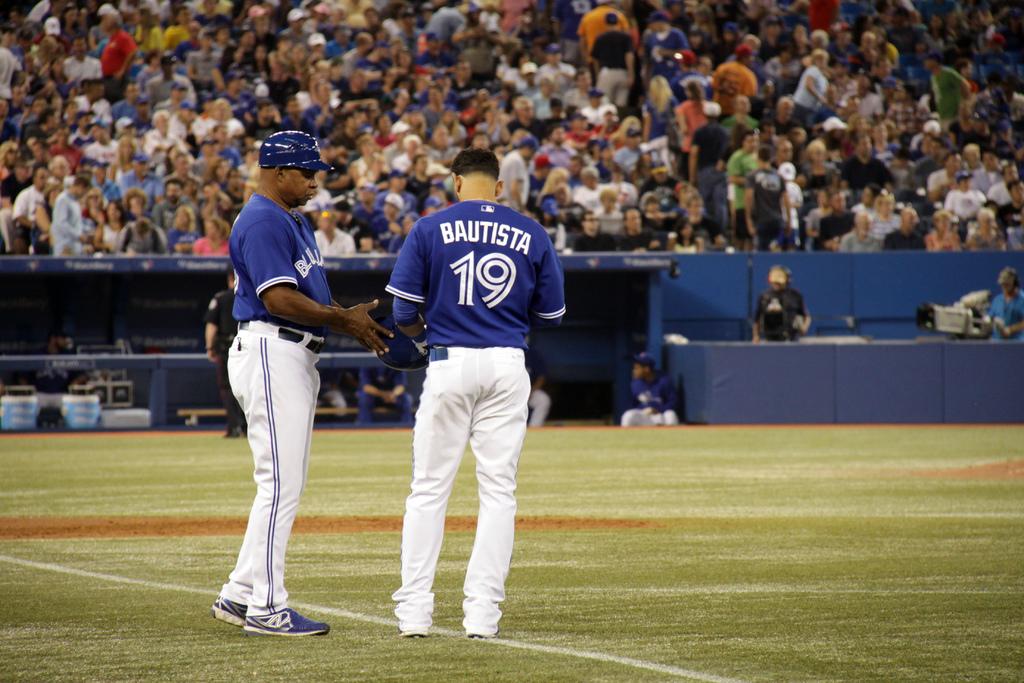What is the last name of the player whose number is 19?
Your answer should be compact. Bautista. 